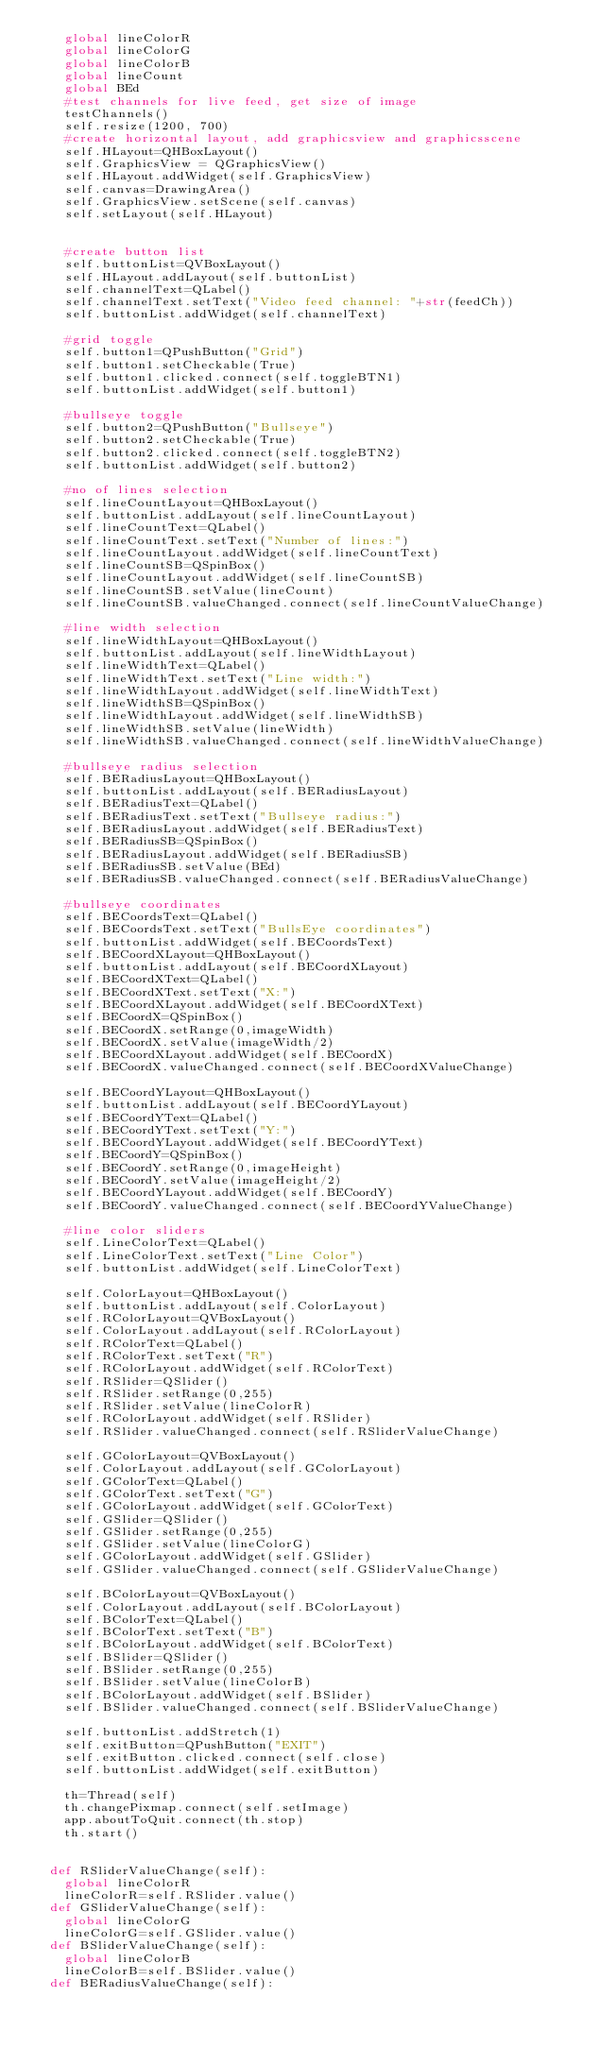<code> <loc_0><loc_0><loc_500><loc_500><_Python_>		global lineColorR
		global lineColorG
		global lineColorB
		global lineCount
		global BEd
		#test channels for live feed, get size of image
		testChannels()
		self.resize(1200, 700)
		#create horizontal layout, add graphicsview and graphicsscene
		self.HLayout=QHBoxLayout()
		self.GraphicsView = QGraphicsView()
		self.HLayout.addWidget(self.GraphicsView)
		self.canvas=DrawingArea()
		self.GraphicsView.setScene(self.canvas)
		self.setLayout(self.HLayout)


		#create button list
		self.buttonList=QVBoxLayout()
		self.HLayout.addLayout(self.buttonList)
		self.channelText=QLabel()
		self.channelText.setText("Video feed channel: "+str(feedCh))
		self.buttonList.addWidget(self.channelText)
		
		#grid toggle
		self.button1=QPushButton("Grid")
		self.button1.setCheckable(True)
		self.button1.clicked.connect(self.toggleBTN1)
		self.buttonList.addWidget(self.button1)	

		#bullseye toggle
		self.button2=QPushButton("Bullseye")
		self.button2.setCheckable(True)
		self.button2.clicked.connect(self.toggleBTN2)
		self.buttonList.addWidget(self.button2)
		
		#no of lines selection
		self.lineCountLayout=QHBoxLayout()
		self.buttonList.addLayout(self.lineCountLayout)
		self.lineCountText=QLabel()
		self.lineCountText.setText("Number of lines:")
		self.lineCountLayout.addWidget(self.lineCountText)
		self.lineCountSB=QSpinBox()
		self.lineCountLayout.addWidget(self.lineCountSB)
		self.lineCountSB.setValue(lineCount)
		self.lineCountSB.valueChanged.connect(self.lineCountValueChange)
		
		#line width selection
		self.lineWidthLayout=QHBoxLayout()
		self.buttonList.addLayout(self.lineWidthLayout)
		self.lineWidthText=QLabel()
		self.lineWidthText.setText("Line width:")
		self.lineWidthLayout.addWidget(self.lineWidthText)
		self.lineWidthSB=QSpinBox()
		self.lineWidthLayout.addWidget(self.lineWidthSB)
		self.lineWidthSB.setValue(lineWidth)
		self.lineWidthSB.valueChanged.connect(self.lineWidthValueChange)
		
		#bullseye radius selection
		self.BERadiusLayout=QHBoxLayout()
		self.buttonList.addLayout(self.BERadiusLayout)
		self.BERadiusText=QLabel()
		self.BERadiusText.setText("Bullseye radius:")
		self.BERadiusLayout.addWidget(self.BERadiusText)
		self.BERadiusSB=QSpinBox()
		self.BERadiusLayout.addWidget(self.BERadiusSB)
		self.BERadiusSB.setValue(BEd)
		self.BERadiusSB.valueChanged.connect(self.BERadiusValueChange)
		
		#bullseye coordinates
		self.BECoordsText=QLabel()
		self.BECoordsText.setText("BullsEye coordinates")
		self.buttonList.addWidget(self.BECoordsText)
		self.BECoordXLayout=QHBoxLayout()
		self.buttonList.addLayout(self.BECoordXLayout)
		self.BECoordXText=QLabel()
		self.BECoordXText.setText("X:")
		self.BECoordXLayout.addWidget(self.BECoordXText)
		self.BECoordX=QSpinBox()
		self.BECoordX.setRange(0,imageWidth)
		self.BECoordX.setValue(imageWidth/2)
		self.BECoordXLayout.addWidget(self.BECoordX)
		self.BECoordX.valueChanged.connect(self.BECoordXValueChange)
		
		self.BECoordYLayout=QHBoxLayout()
		self.buttonList.addLayout(self.BECoordYLayout)
		self.BECoordYText=QLabel()
		self.BECoordYText.setText("Y:")
		self.BECoordYLayout.addWidget(self.BECoordYText)
		self.BECoordY=QSpinBox()
		self.BECoordY.setRange(0,imageHeight)
		self.BECoordY.setValue(imageHeight/2)
		self.BECoordYLayout.addWidget(self.BECoordY)
		self.BECoordY.valueChanged.connect(self.BECoordYValueChange)
		
		#line color sliders
		self.LineColorText=QLabel()
		self.LineColorText.setText("Line Color")
		self.buttonList.addWidget(self.LineColorText)
		
		self.ColorLayout=QHBoxLayout()
		self.buttonList.addLayout(self.ColorLayout)
		self.RColorLayout=QVBoxLayout()
		self.ColorLayout.addLayout(self.RColorLayout)
		self.RColorText=QLabel()
		self.RColorText.setText("R")
		self.RColorLayout.addWidget(self.RColorText)
		self.RSlider=QSlider()
		self.RSlider.setRange(0,255)
		self.RSlider.setValue(lineColorR)
		self.RColorLayout.addWidget(self.RSlider)
		self.RSlider.valueChanged.connect(self.RSliderValueChange)
		
		self.GColorLayout=QVBoxLayout()
		self.ColorLayout.addLayout(self.GColorLayout)
		self.GColorText=QLabel()
		self.GColorText.setText("G")
		self.GColorLayout.addWidget(self.GColorText)
		self.GSlider=QSlider()
		self.GSlider.setRange(0,255)
		self.GSlider.setValue(lineColorG)
		self.GColorLayout.addWidget(self.GSlider)
		self.GSlider.valueChanged.connect(self.GSliderValueChange)
		
		self.BColorLayout=QVBoxLayout()
		self.ColorLayout.addLayout(self.BColorLayout)
		self.BColorText=QLabel()
		self.BColorText.setText("B")
		self.BColorLayout.addWidget(self.BColorText)
		self.BSlider=QSlider()
		self.BSlider.setRange(0,255)
		self.BSlider.setValue(lineColorB)
		self.BColorLayout.addWidget(self.BSlider)
		self.BSlider.valueChanged.connect(self.BSliderValueChange)
		
		self.buttonList.addStretch(1)
		self.exitButton=QPushButton("EXIT")
		self.exitButton.clicked.connect(self.close)
		self.buttonList.addWidget(self.exitButton)
		
		th=Thread(self)
		th.changePixmap.connect(self.setImage)
		app.aboutToQuit.connect(th.stop)
		th.start()


	def RSliderValueChange(self):
		global lineColorR
		lineColorR=self.RSlider.value()
	def GSliderValueChange(self):
		global lineColorG
		lineColorG=self.GSlider.value()
	def BSliderValueChange(self):
		global lineColorB
		lineColorB=self.BSlider.value()
	def BERadiusValueChange(self):</code> 